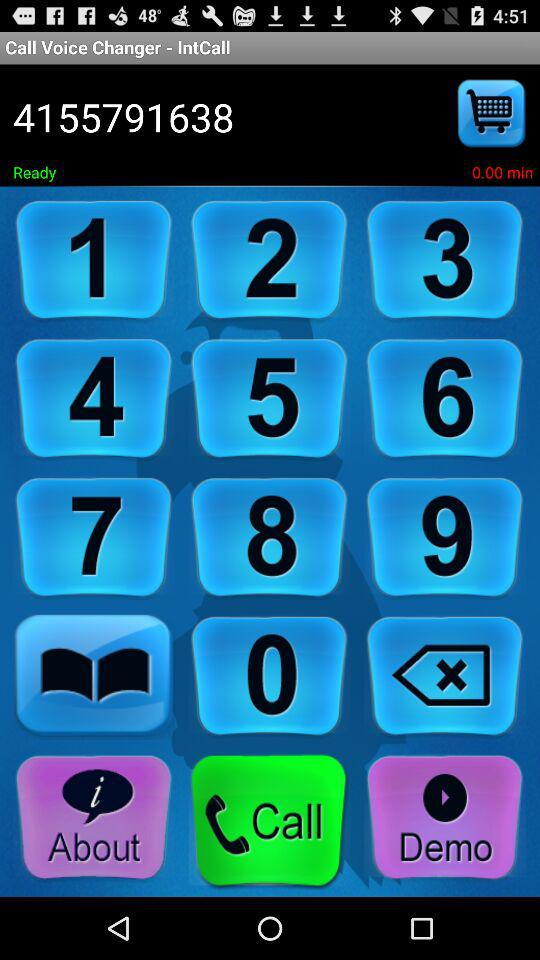How much time is left on the call?
Answer the question using a single word or phrase. 0.00 min 